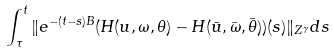Convert formula to latex. <formula><loc_0><loc_0><loc_500><loc_500>\int ^ { t } _ { \tau } \| e ^ { - ( t - s ) B } ( H ( u , \omega , \theta ) - H ( \bar { u } , \bar { \omega } , \bar { \theta } ) ) ( s ) \| _ { Z ^ { \gamma } } d s</formula> 